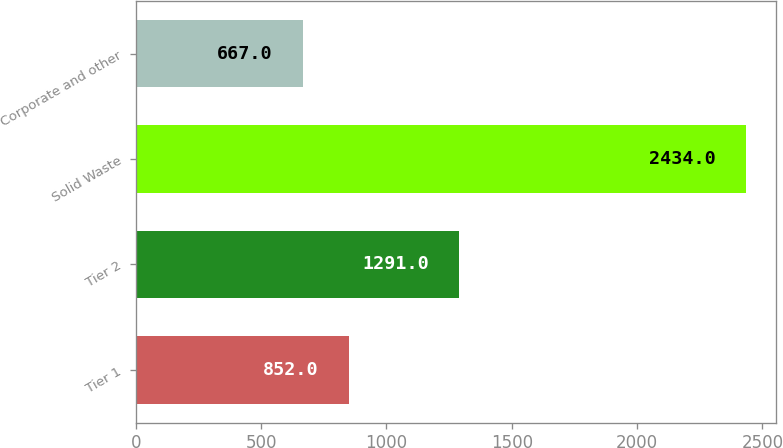Convert chart to OTSL. <chart><loc_0><loc_0><loc_500><loc_500><bar_chart><fcel>Tier 1<fcel>Tier 2<fcel>Solid Waste<fcel>Corporate and other<nl><fcel>852<fcel>1291<fcel>2434<fcel>667<nl></chart> 